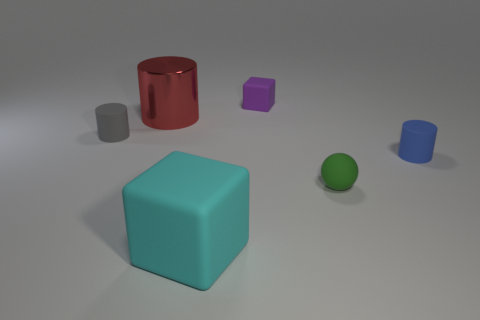How many small blue objects are made of the same material as the big cyan object?
Provide a succinct answer. 1. Are there any small green rubber spheres in front of the big cyan matte object that is on the left side of the small object that is in front of the blue cylinder?
Provide a short and direct response. No. The purple object that is the same material as the small gray thing is what shape?
Your answer should be compact. Cube. Are there more large green rubber cylinders than gray matte cylinders?
Offer a very short reply. No. There is a big red shiny object; is its shape the same as the big object in front of the small rubber sphere?
Ensure brevity in your answer.  No. What material is the purple cube?
Keep it short and to the point. Rubber. The block behind the big red shiny thing that is behind the matte cube in front of the big red cylinder is what color?
Provide a short and direct response. Purple. What is the material of the tiny gray thing that is the same shape as the blue thing?
Your answer should be compact. Rubber. How many gray matte objects have the same size as the purple matte thing?
Ensure brevity in your answer.  1. What number of small gray cylinders are there?
Your response must be concise. 1. 